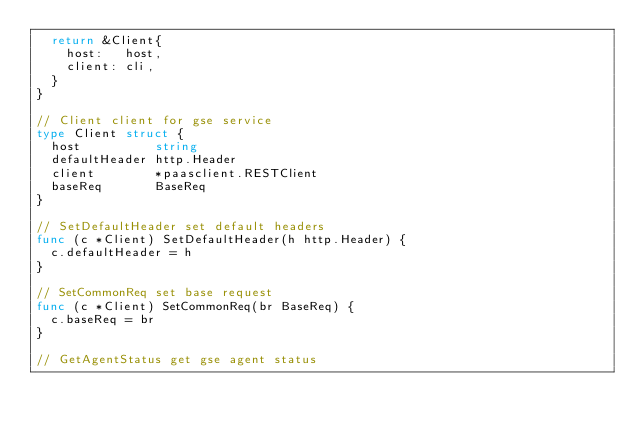<code> <loc_0><loc_0><loc_500><loc_500><_Go_>	return &Client{
		host:   host,
		client: cli,
	}
}

// Client client for gse service
type Client struct {
	host          string
	defaultHeader http.Header
	client        *paasclient.RESTClient
	baseReq       BaseReq
}

// SetDefaultHeader set default headers
func (c *Client) SetDefaultHeader(h http.Header) {
	c.defaultHeader = h
}

// SetCommonReq set base request
func (c *Client) SetCommonReq(br BaseReq) {
	c.baseReq = br
}

// GetAgentStatus get gse agent status</code> 